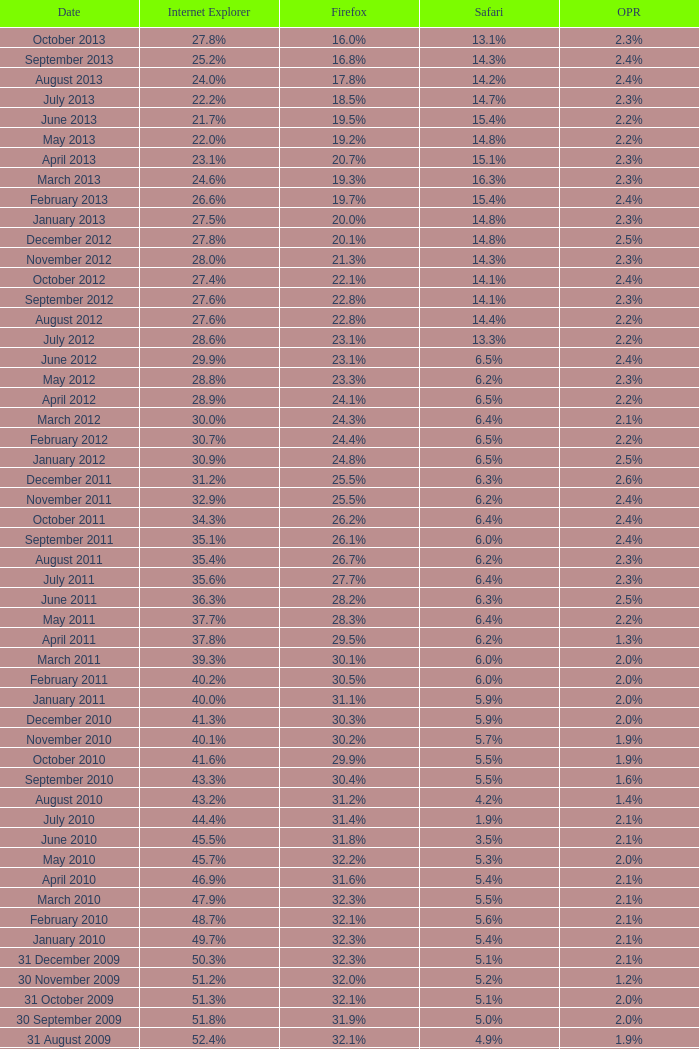What is the date when internet explorer was 62.2% 31 January 2008. 